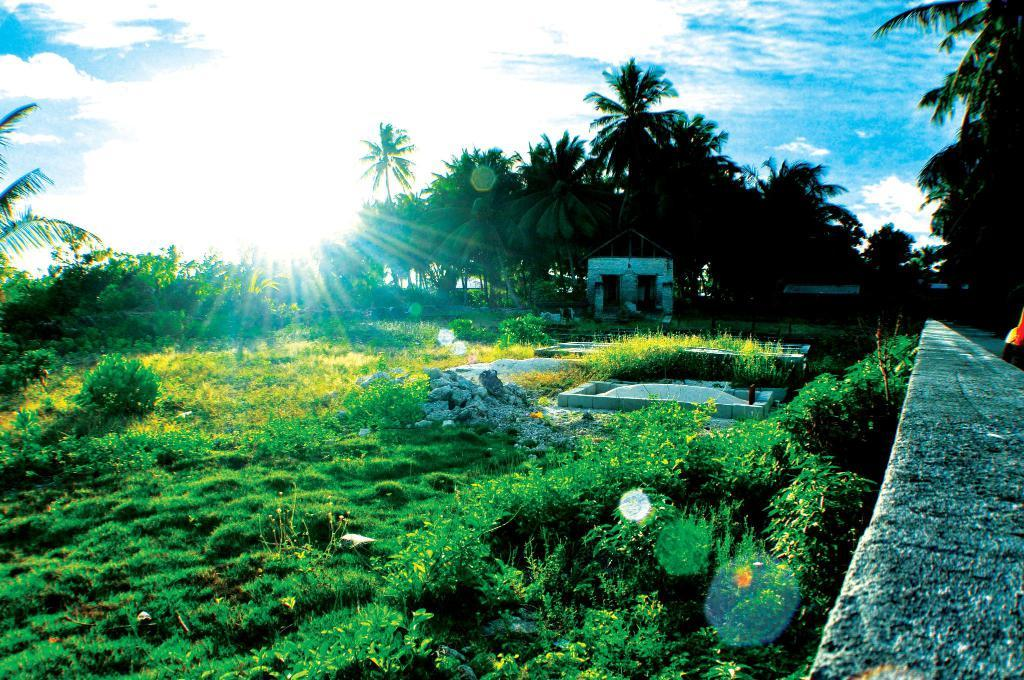What type of vegetation can be seen in the image? There are trees in the image. What other natural elements are present in the image? There are stones and grass visible in the image. What type of structure is in the image? There is a wall in the image. What can be seen in the background of the image? The sky is visible in the background of the image, and there are clouds in the sky. What type of invention is being demonstrated in the image? There is no invention being demonstrated in the image; it features trees, stones, grass, a wall, and a sky with clouds. What color is the toothpaste in the image? There is no toothpaste present in the image. 